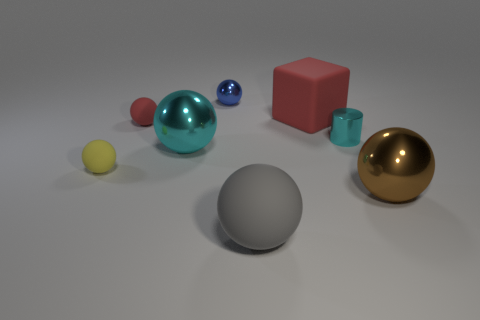There is a object that is the same color as the tiny cylinder; what shape is it?
Provide a short and direct response. Sphere. What is the large gray ball made of?
Your response must be concise. Rubber. How many objects are big cyan metallic things or small cyan cylinders?
Provide a short and direct response. 2. There is a thing that is to the right of the tiny cyan metal cylinder; is it the same size as the gray rubber thing on the right side of the red sphere?
Your response must be concise. Yes. How many other things are the same size as the gray ball?
Your response must be concise. 3. How many objects are either large metallic objects to the left of the tiny blue object or tiny things behind the small red rubber thing?
Give a very brief answer. 2. Is the blue sphere made of the same material as the sphere to the right of the metallic cylinder?
Your answer should be compact. Yes. How many other things are there of the same shape as the tiny yellow matte thing?
Provide a succinct answer. 5. The big ball that is behind the small sphere in front of the large metallic object left of the small cyan metal object is made of what material?
Provide a short and direct response. Metal. Are there an equal number of large gray rubber things behind the brown ball and cyan cylinders?
Make the answer very short. No. 